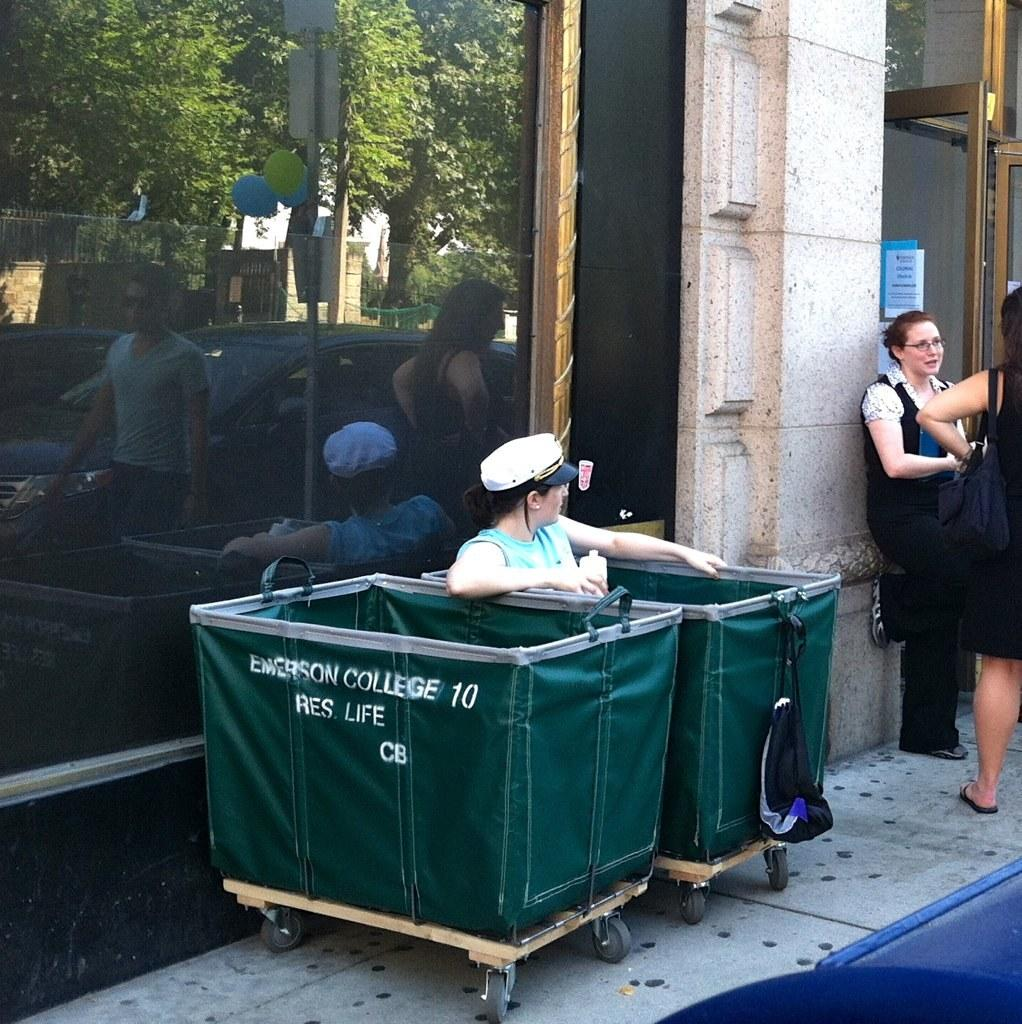Provide a one-sentence caption for the provided image. A person sits in a green container that is one of two owned by Emerson College. 